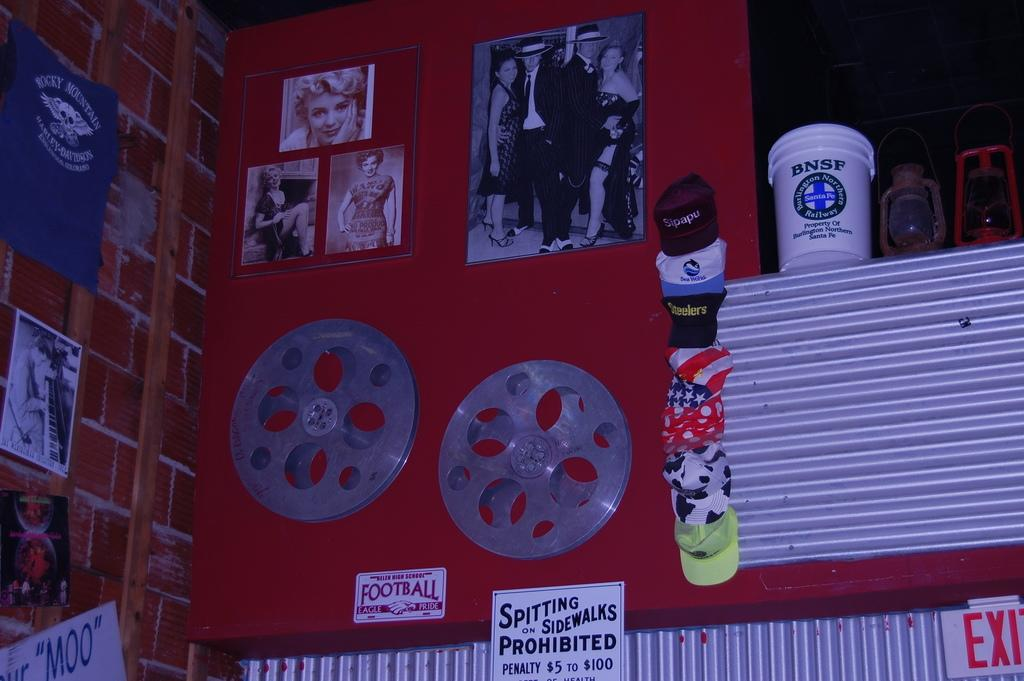<image>
Offer a succinct explanation of the picture presented. A sign that says that spiting on sidewalks is prohibited hangs on a red wall. 